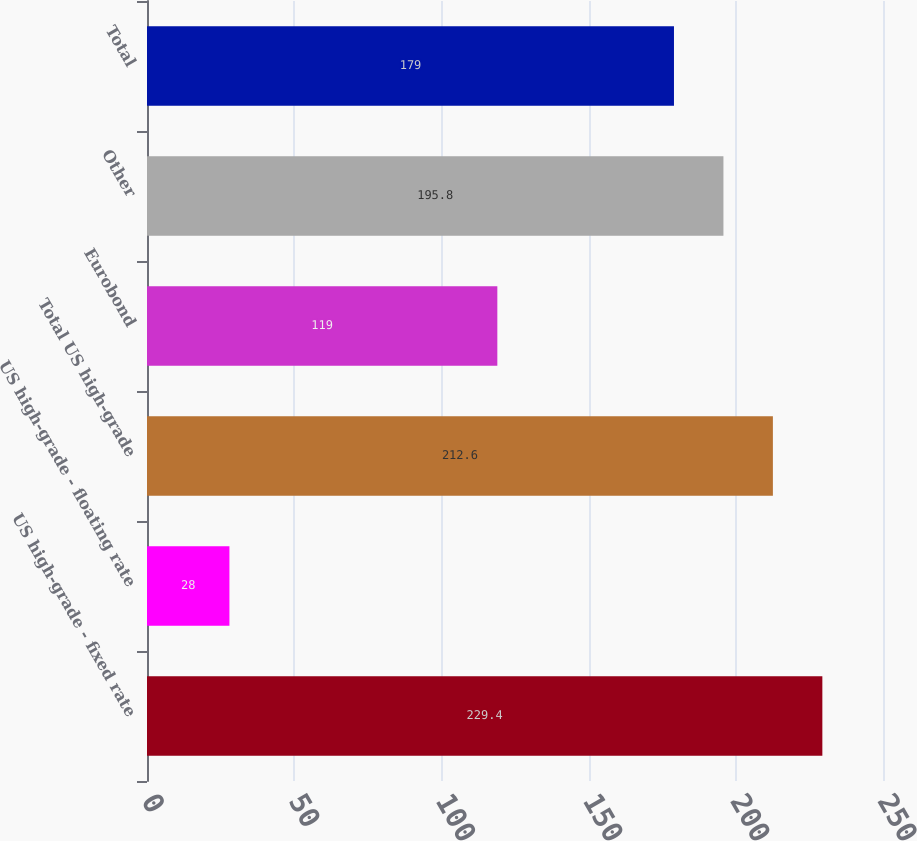<chart> <loc_0><loc_0><loc_500><loc_500><bar_chart><fcel>US high-grade - fixed rate<fcel>US high-grade - floating rate<fcel>Total US high-grade<fcel>Eurobond<fcel>Other<fcel>Total<nl><fcel>229.4<fcel>28<fcel>212.6<fcel>119<fcel>195.8<fcel>179<nl></chart> 